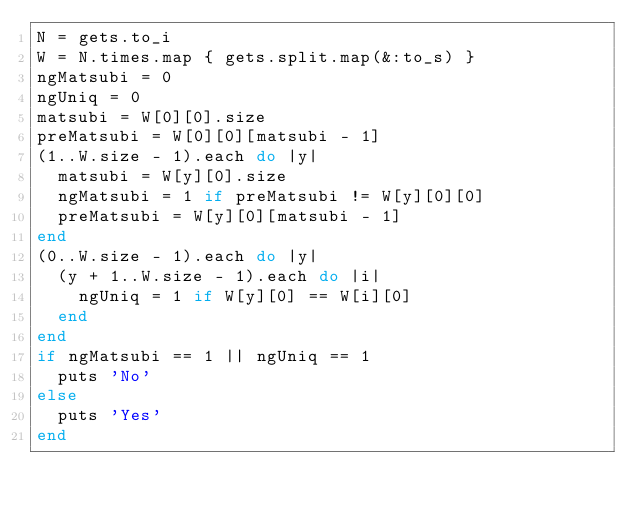Convert code to text. <code><loc_0><loc_0><loc_500><loc_500><_Ruby_>N = gets.to_i
W = N.times.map { gets.split.map(&:to_s) }
ngMatsubi = 0
ngUniq = 0
matsubi = W[0][0].size
preMatsubi = W[0][0][matsubi - 1]
(1..W.size - 1).each do |y|
  matsubi = W[y][0].size
  ngMatsubi = 1 if preMatsubi != W[y][0][0]
  preMatsubi = W[y][0][matsubi - 1]
end
(0..W.size - 1).each do |y|
  (y + 1..W.size - 1).each do |i|
    ngUniq = 1 if W[y][0] == W[i][0]
  end
end
if ngMatsubi == 1 || ngUniq == 1
  puts 'No'
else
  puts 'Yes'
end</code> 